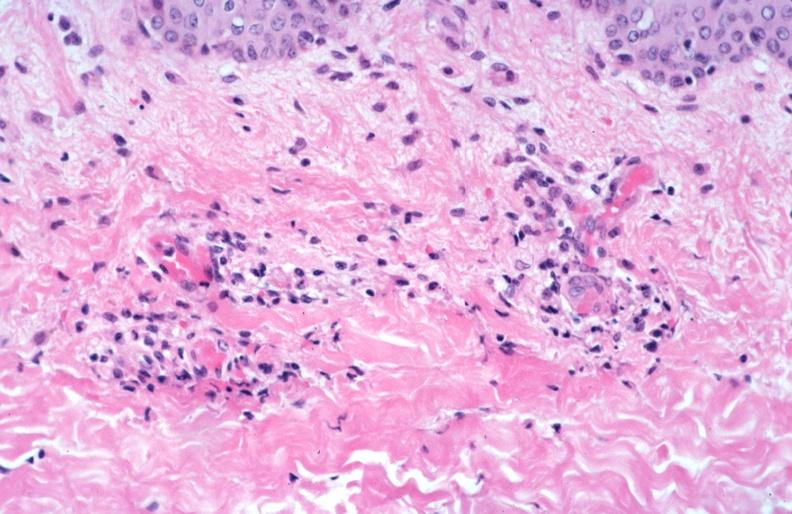s muscle spotted fever, vasculitis?
Answer the question using a single word or phrase. No 